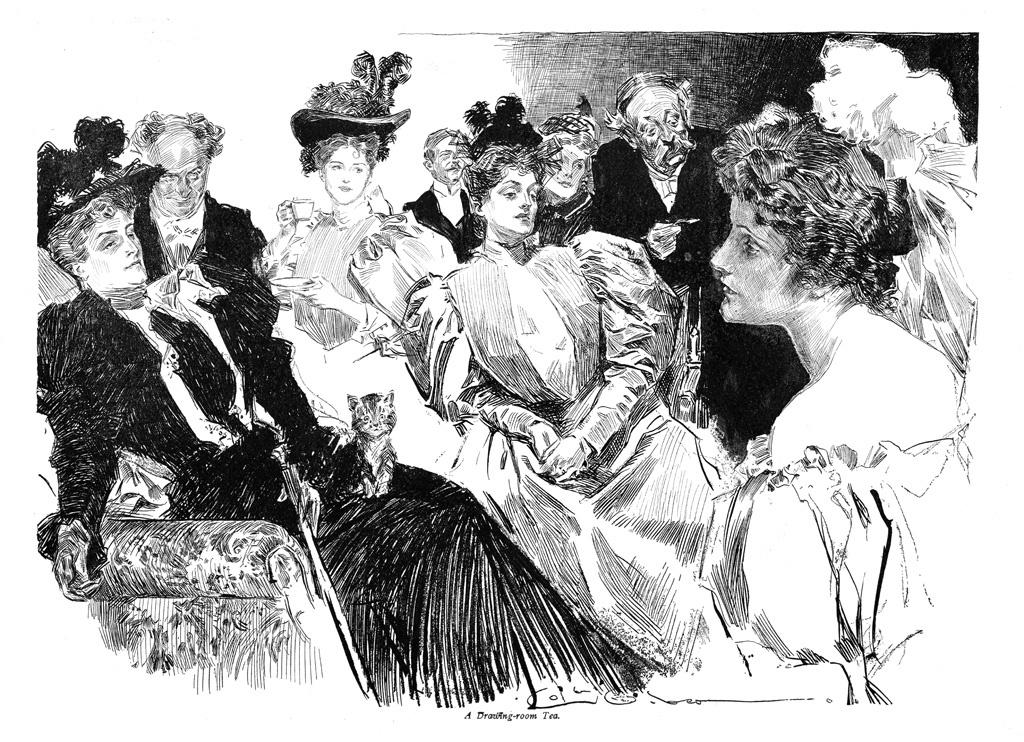What is the color scheme of the image? The image is black and white. What can be seen in the image besides the color scheme? There are people sitting on a sofa in the image. How many cattle are present in the image? There are no cattle present in the image. What is the maid doing in the image? There is no maid present in the image. 